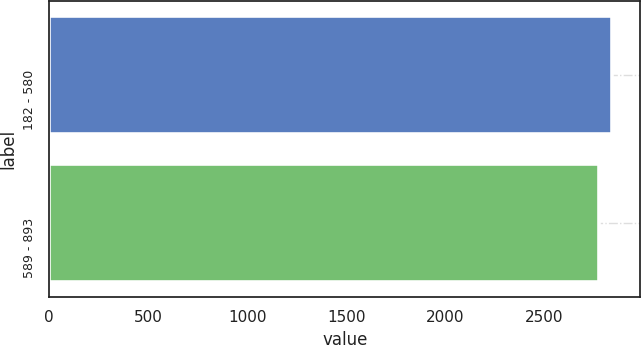<chart> <loc_0><loc_0><loc_500><loc_500><bar_chart><fcel>182 - 580<fcel>589 - 893<nl><fcel>2843<fcel>2779<nl></chart> 